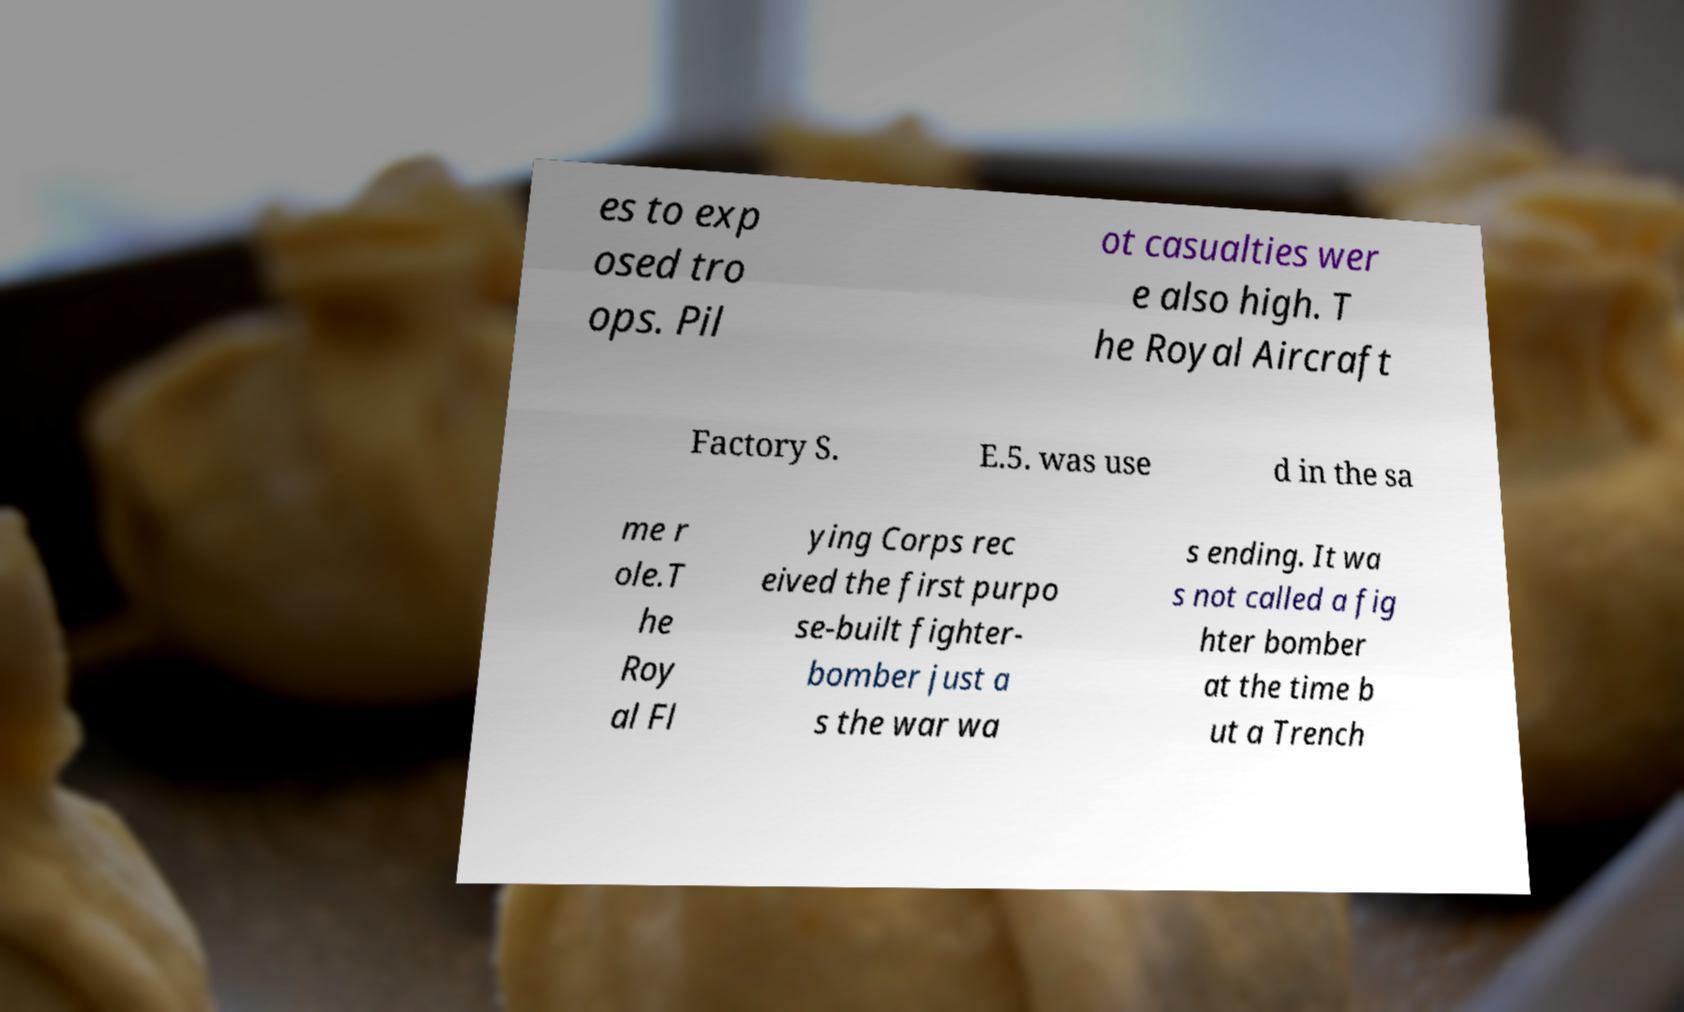Can you read and provide the text displayed in the image?This photo seems to have some interesting text. Can you extract and type it out for me? es to exp osed tro ops. Pil ot casualties wer e also high. T he Royal Aircraft Factory S. E.5. was use d in the sa me r ole.T he Roy al Fl ying Corps rec eived the first purpo se-built fighter- bomber just a s the war wa s ending. It wa s not called a fig hter bomber at the time b ut a Trench 